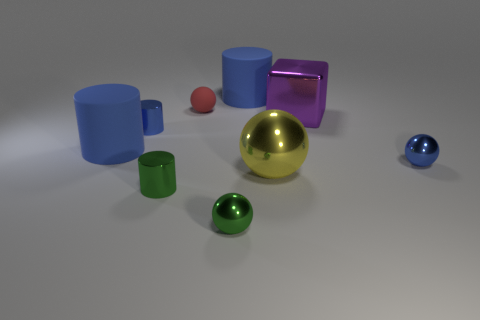Are there any other things that are the same shape as the big purple thing?
Make the answer very short. No. How many other things are there of the same size as the red object?
Make the answer very short. 4. How many small green objects are the same material as the large sphere?
Provide a succinct answer. 2. There is a big blue matte thing that is in front of the purple block; what is its shape?
Keep it short and to the point. Cylinder. Is the material of the small blue ball the same as the big blue cylinder on the left side of the red sphere?
Give a very brief answer. No. Are any small blue metal cylinders visible?
Make the answer very short. Yes. Is there a blue cylinder right of the large matte cylinder left of the tiny green cylinder that is to the left of the red matte thing?
Provide a short and direct response. Yes. What number of small objects are gray rubber cylinders or red balls?
Offer a very short reply. 1. What color is the metal sphere that is the same size as the purple block?
Keep it short and to the point. Yellow. How many small things are left of the purple metallic object?
Offer a terse response. 4. 